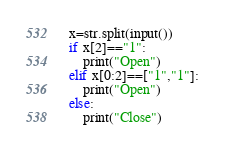<code> <loc_0><loc_0><loc_500><loc_500><_Python_>x=str.split(input())
if x[2]=="1":
	print("Open")
elif x[0:2]==["1","1"]:
	print("Open")
else:
	print("Close")</code> 